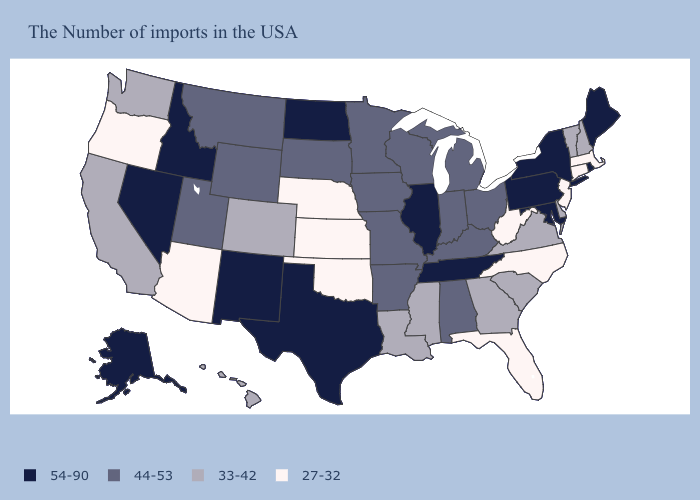Among the states that border Colorado , does New Mexico have the highest value?
Give a very brief answer. Yes. Does Oklahoma have the lowest value in the South?
Write a very short answer. Yes. Is the legend a continuous bar?
Concise answer only. No. What is the value of Oklahoma?
Keep it brief. 27-32. Does the map have missing data?
Keep it brief. No. Does New Jersey have the highest value in the Northeast?
Short answer required. No. Which states hav the highest value in the Northeast?
Write a very short answer. Maine, Rhode Island, New York, Pennsylvania. What is the highest value in states that border Indiana?
Be succinct. 54-90. Does Nebraska have the lowest value in the USA?
Keep it brief. Yes. Name the states that have a value in the range 33-42?
Keep it brief. New Hampshire, Vermont, Delaware, Virginia, South Carolina, Georgia, Mississippi, Louisiana, Colorado, California, Washington, Hawaii. Does Georgia have the highest value in the USA?
Give a very brief answer. No. How many symbols are there in the legend?
Short answer required. 4. Does California have the same value as Arkansas?
Write a very short answer. No. What is the value of Idaho?
Write a very short answer. 54-90. What is the value of Maine?
Be succinct. 54-90. 